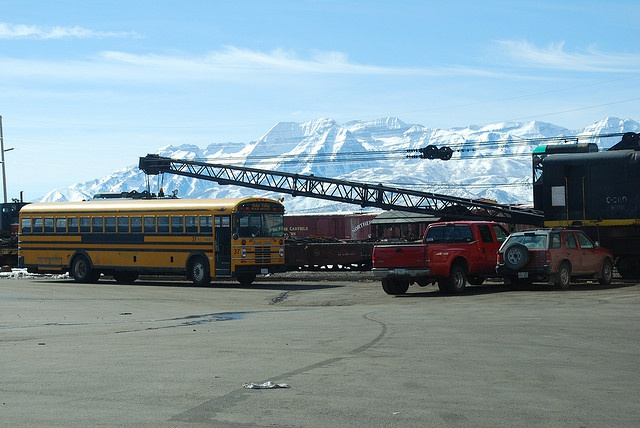Describe the objects in this image and their specific colors. I can see bus in lightblue, black, maroon, and blue tones, truck in lightblue, black, maroon, gray, and purple tones, car in lightblue, black, gray, and teal tones, train in lightblue, black, gray, and white tones, and train in lightblue, black, navy, blue, and gray tones in this image. 